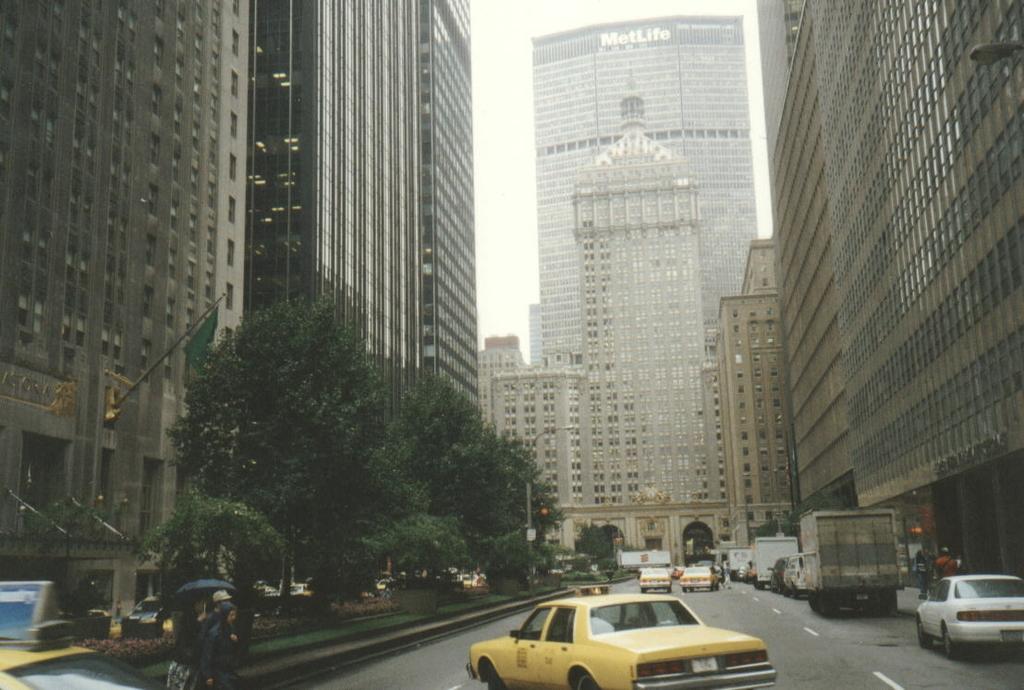What name is on the building?
Make the answer very short. Metlife. The marriott hotel?
Offer a very short reply. No. 